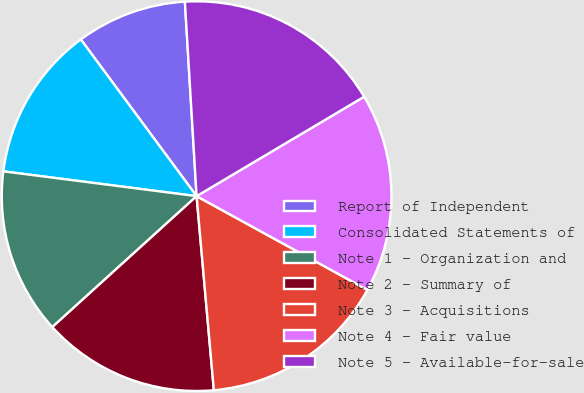<chart> <loc_0><loc_0><loc_500><loc_500><pie_chart><fcel>Report of Independent<fcel>Consolidated Statements of<fcel>Note 1 - Organization and<fcel>Note 2 - Summary of<fcel>Note 3 - Acquisitions<fcel>Note 4 - Fair value<fcel>Note 5 - Available-for-sale<nl><fcel>9.17%<fcel>12.84%<fcel>13.76%<fcel>14.68%<fcel>15.6%<fcel>16.51%<fcel>17.43%<nl></chart> 